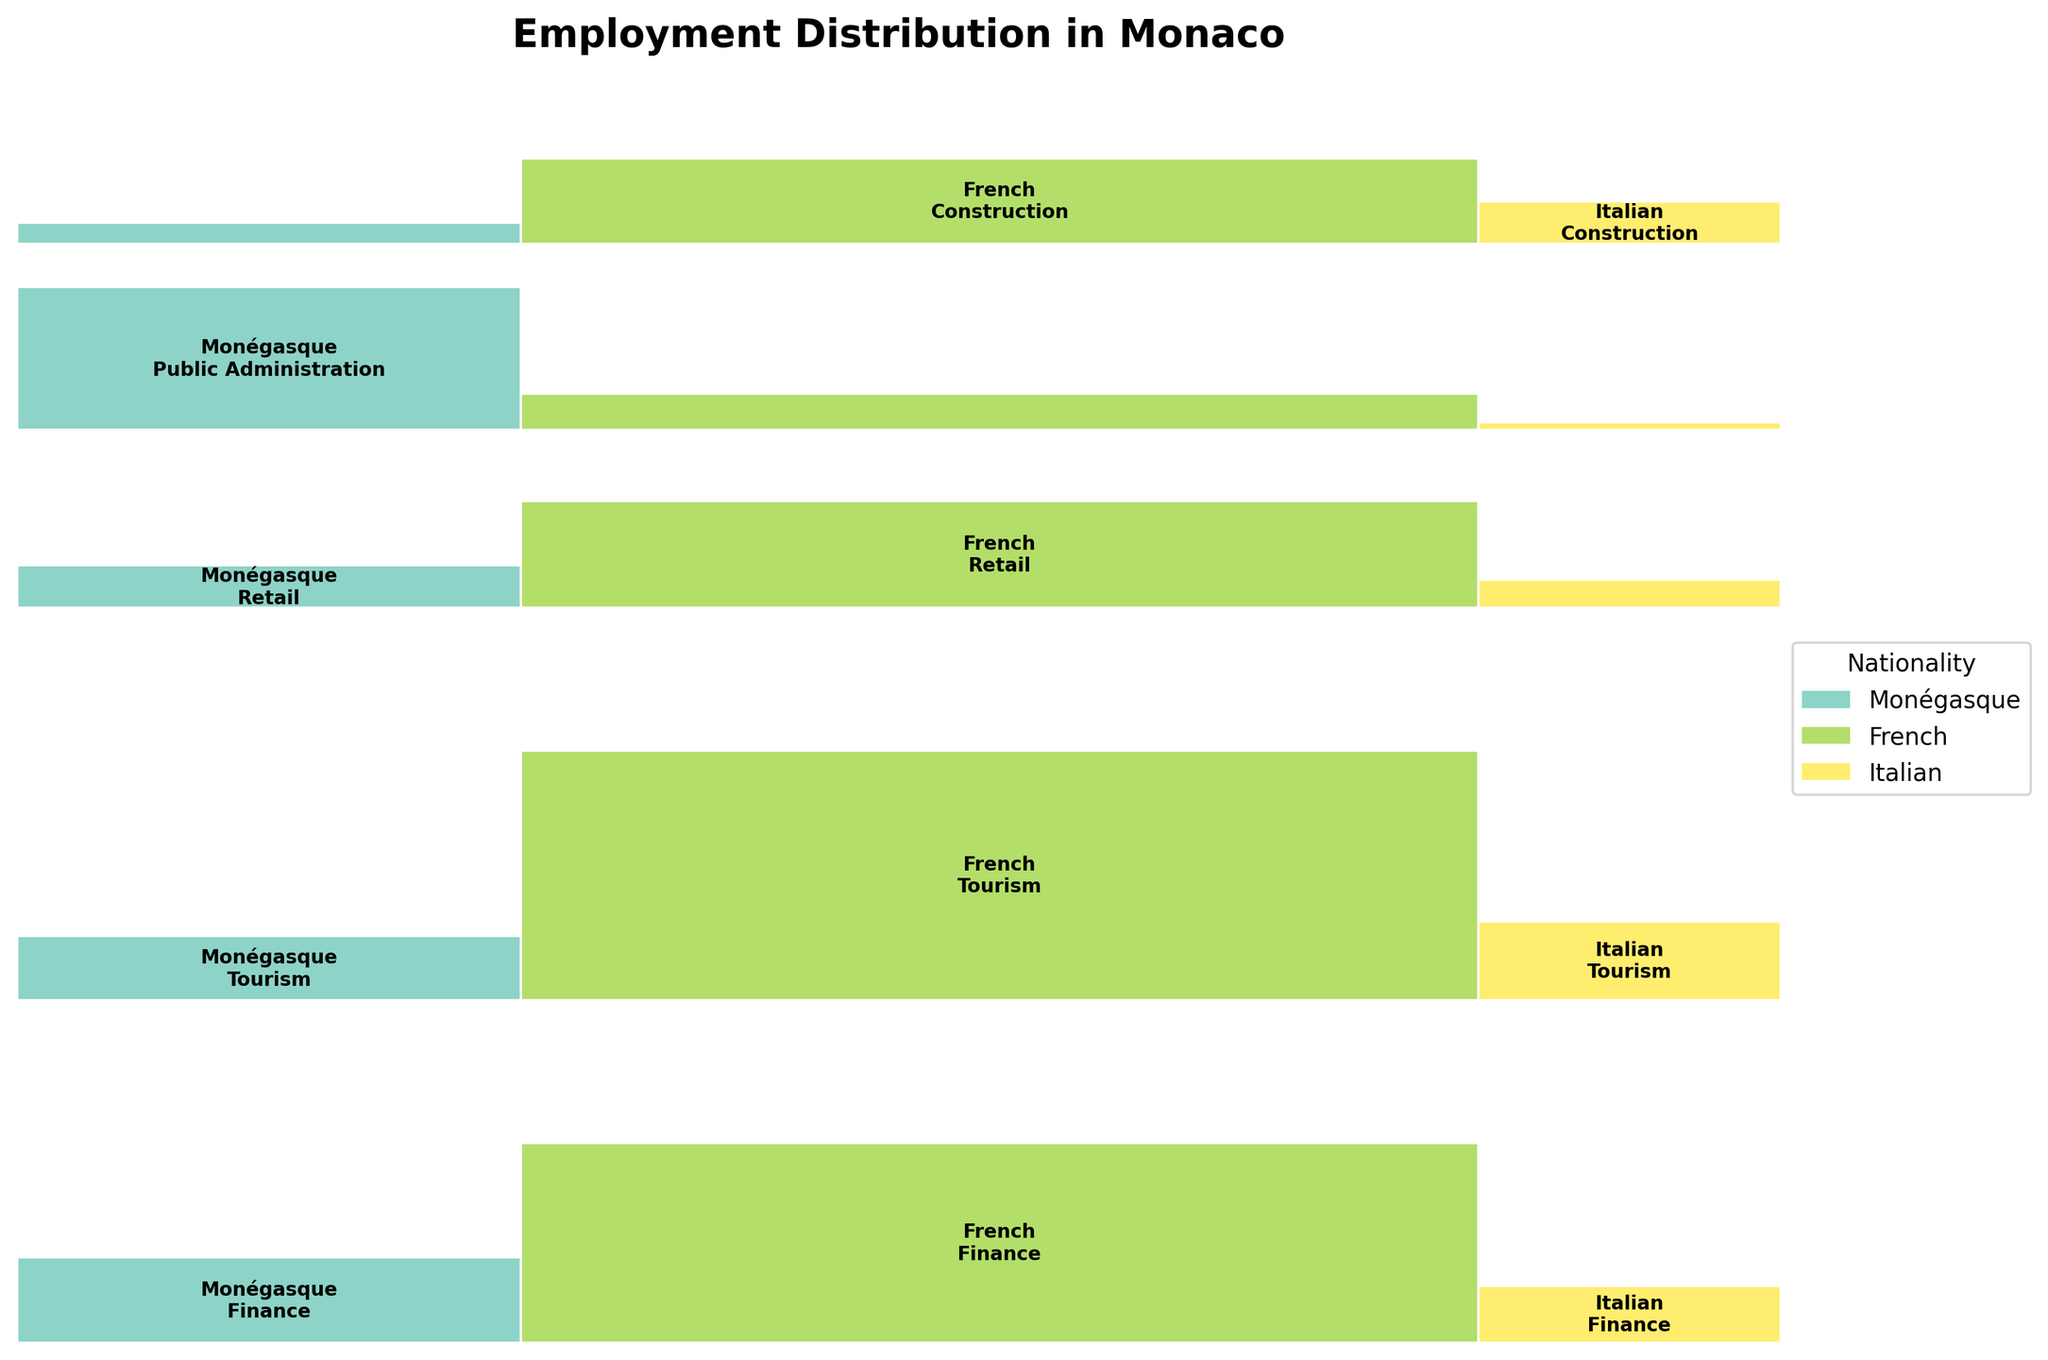What is the title of the plot? The title is usually located at the top of the figure and is meant to give a summary of what the plot is about. Upon examining the plot, the title can be read directly.
Answer: Employment Distribution in Monaco How many nationalities are represented in the plot? By examining the legend or the labels within the plot, one can count the number of different nationalities that are represented.
Answer: 3 Which industry employs the most people overall? To determine which industry employs the most people, one should look at the height of each industry's section in the plot. The industry with the largest total height employs the most people.
Answer: Finance In which industry do Monégasque employees have the highest representation? By comparing the relative sizes within each industry and looking specifically at the sections labeled "Monégasque," we can see in which industry Monégasque employees account for the greatest proportion of the section.
Answer: Public Administration Compare the employment distribution of French employees between the Finance and Tourism industries. Which industry has more French employees? Look at the sections labeled "French" in both the Finance and Tourism industries. The industry where the section is larger represents more French employees.
Answer: Tourism Between Italian employees in Retail and Construction, which industry has a larger representation? Identify the sizes of the sections labeled "Italian" within the Retail and Construction industries. The industry with the larger section has a greater representation.
Answer: Construction What is the approximate proportion of Monégasque employees in the Public Administration industry? Identify the section that represents Monégasque employees in Public Administration and compare its size to the entire Public Administration section. This proportion provides an approximation of Monégasque representation.
Answer: Around 80% In the plot, which nationality has the smallest representation in the Retail industry? Look at the sections within the Retail industry, identify the smallest section, and note the nationality labeled there.
Answer: Italian Identify the industry with the smallest total employment of French employees. Look at all sections labeled "French" and find the section with the smallest total height across industries.
Answer: Public Administration For the Tourism industry, how do the proportions of Monégasque and Italian employees compare? Compare the sizes of the sections labeled "Monégasque" and "Italian" within the Tourism industry to see which one is larger, representing a greater proportion.
Answer: Italian employees are more represented than Monégasque 